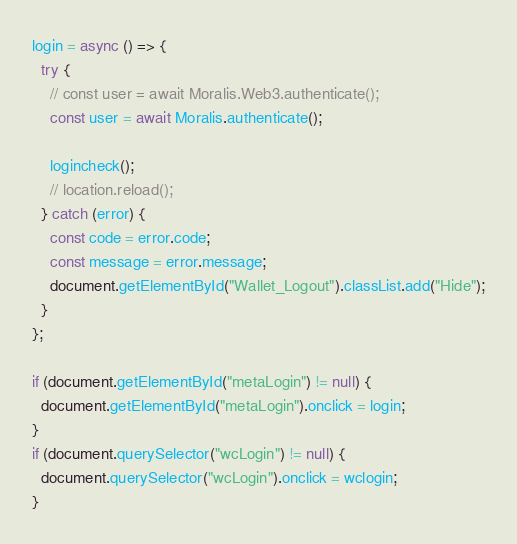Convert code to text. <code><loc_0><loc_0><loc_500><loc_500><_JavaScript_>login = async () => {
  try {
    // const user = await Moralis.Web3.authenticate();
    const user = await Moralis.authenticate();

    logincheck();
    // location.reload();
  } catch (error) {
    const code = error.code;
    const message = error.message;
    document.getElementById("Wallet_Logout").classList.add("Hide");
  }
};

if (document.getElementById("metaLogin") != null) {
  document.getElementById("metaLogin").onclick = login;
}
if (document.querySelector("wcLogin") != null) {
  document.querySelector("wcLogin").onclick = wclogin;
}
</code> 